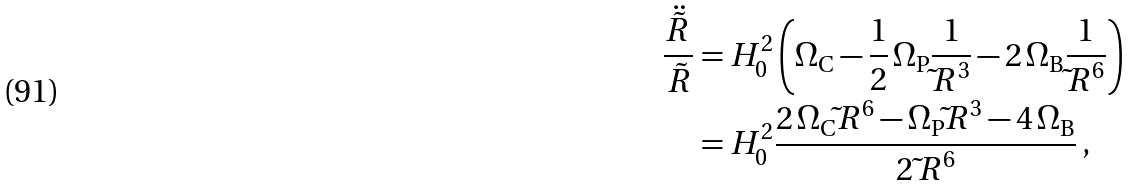<formula> <loc_0><loc_0><loc_500><loc_500>\frac { \ddot { \tilde { R } } } { \, \tilde { R } } & = H _ { 0 } ^ { 2 } \left ( \Omega _ { \text  C}         - \frac{1}{2} \, \Omega_{\text  P} \frac{1}{{\tilde{ }R} ^ { 3 } } - 2 \, \Omega _ { \text  B} \frac{1}{{\tilde{ }R} ^ { 6 } } \right ) \\ & = H _ { 0 } ^ { 2 } \frac { 2 \, \Omega _ { \text  C} {\tilde{ } R } ^ { 6 } - \Omega _ { \text  P} {\tilde{ } R } ^ { 3 } - 4 \, \Omega _ { \text  B}}        {2 \, {\tilde{ } R } ^ { 6 } } \, ,</formula> 